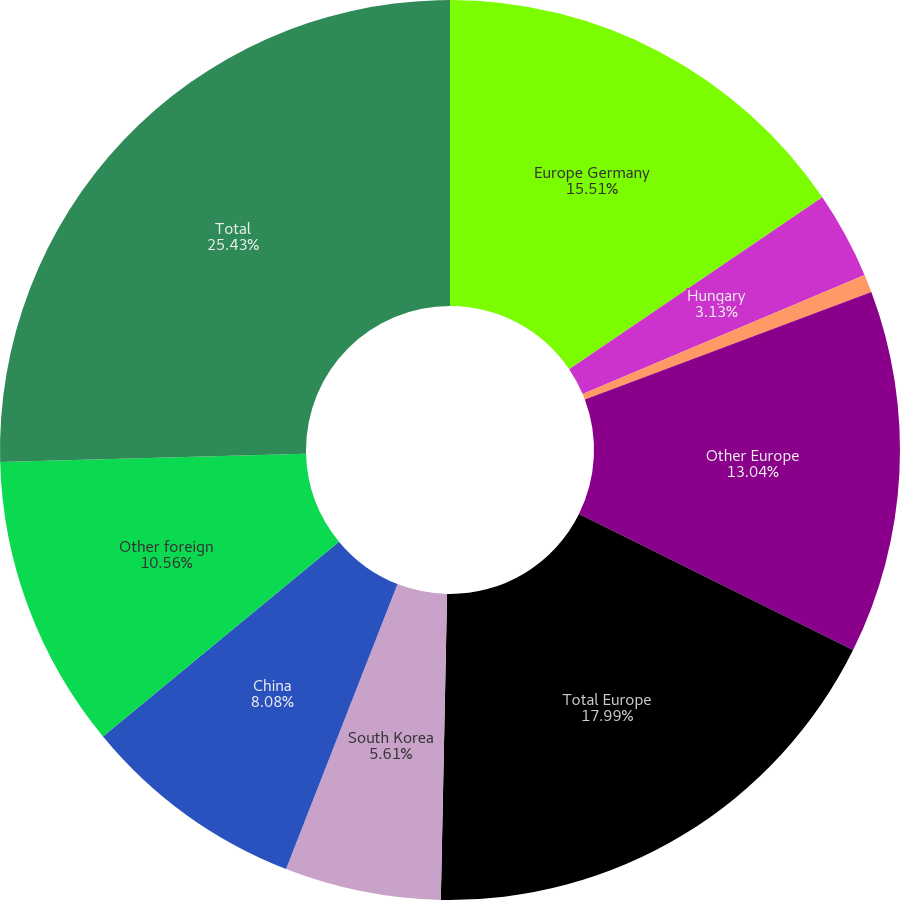Convert chart. <chart><loc_0><loc_0><loc_500><loc_500><pie_chart><fcel>Europe Germany<fcel>Hungary<fcel>France<fcel>Other Europe<fcel>Total Europe<fcel>South Korea<fcel>China<fcel>Other foreign<fcel>Total<nl><fcel>15.51%<fcel>3.13%<fcel>0.65%<fcel>13.04%<fcel>17.99%<fcel>5.61%<fcel>8.08%<fcel>10.56%<fcel>25.42%<nl></chart> 